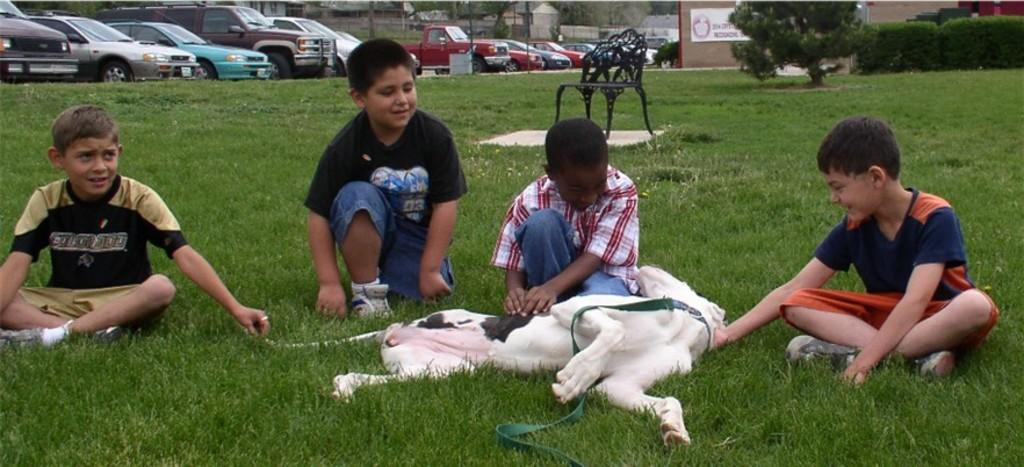How many boys are present in the image? There are 4 boys in the image. Where are the boys sitting? The boys are sitting in a garden. What other living creature is present in the image? There is a dog in the image. What can be seen in the background of the image? There is a car, a building, a chair, and a tree in the background of the image. What type of watch is the tiger wearing in the image? There is no tiger present in the image, and therefore no watch to be worn. 